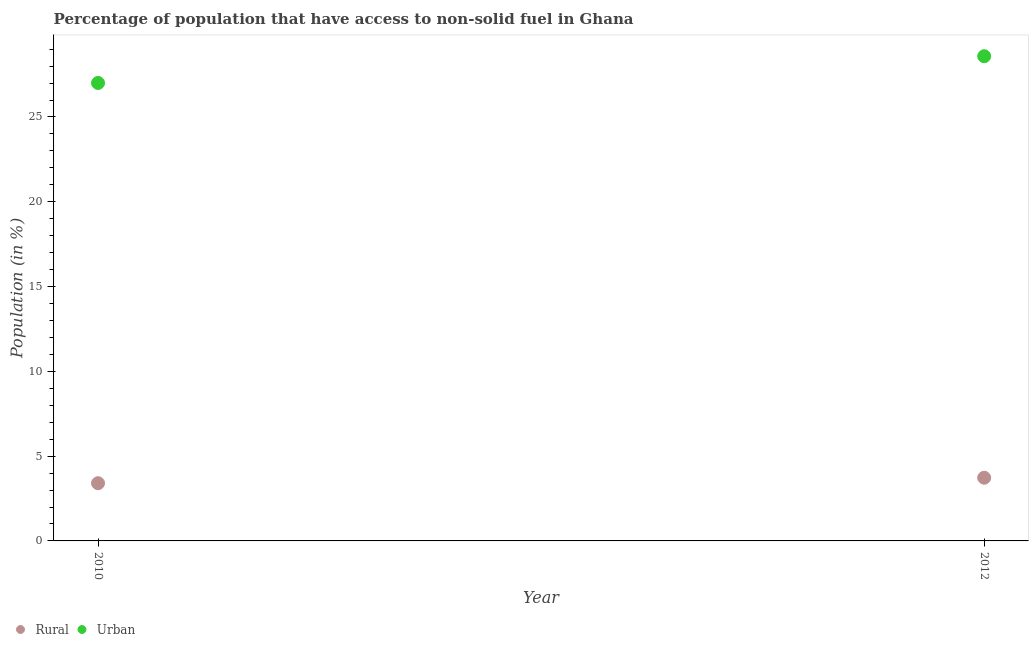How many different coloured dotlines are there?
Your response must be concise. 2. Is the number of dotlines equal to the number of legend labels?
Ensure brevity in your answer.  Yes. What is the rural population in 2010?
Ensure brevity in your answer.  3.4. Across all years, what is the maximum urban population?
Give a very brief answer. 28.58. Across all years, what is the minimum rural population?
Offer a very short reply. 3.4. In which year was the rural population maximum?
Offer a terse response. 2012. In which year was the rural population minimum?
Your answer should be very brief. 2010. What is the total rural population in the graph?
Offer a terse response. 7.13. What is the difference between the rural population in 2010 and that in 2012?
Give a very brief answer. -0.32. What is the difference between the rural population in 2010 and the urban population in 2012?
Your answer should be very brief. -25.18. What is the average rural population per year?
Ensure brevity in your answer.  3.57. In the year 2010, what is the difference between the rural population and urban population?
Give a very brief answer. -23.6. What is the ratio of the rural population in 2010 to that in 2012?
Your response must be concise. 0.91. Is the rural population in 2010 less than that in 2012?
Make the answer very short. Yes. In how many years, is the rural population greater than the average rural population taken over all years?
Make the answer very short. 1. Does the urban population monotonically increase over the years?
Offer a terse response. Yes. Is the urban population strictly greater than the rural population over the years?
Ensure brevity in your answer.  Yes. How many years are there in the graph?
Your answer should be very brief. 2. How many legend labels are there?
Your answer should be compact. 2. How are the legend labels stacked?
Give a very brief answer. Horizontal. What is the title of the graph?
Your response must be concise. Percentage of population that have access to non-solid fuel in Ghana. Does "Diesel" appear as one of the legend labels in the graph?
Offer a terse response. No. What is the Population (in %) in Rural in 2010?
Provide a short and direct response. 3.4. What is the Population (in %) in Urban in 2010?
Your response must be concise. 27.01. What is the Population (in %) of Rural in 2012?
Make the answer very short. 3.73. What is the Population (in %) in Urban in 2012?
Offer a terse response. 28.58. Across all years, what is the maximum Population (in %) of Rural?
Offer a terse response. 3.73. Across all years, what is the maximum Population (in %) of Urban?
Your answer should be very brief. 28.58. Across all years, what is the minimum Population (in %) of Rural?
Give a very brief answer. 3.4. Across all years, what is the minimum Population (in %) in Urban?
Offer a terse response. 27.01. What is the total Population (in %) in Rural in the graph?
Offer a very short reply. 7.13. What is the total Population (in %) of Urban in the graph?
Provide a short and direct response. 55.59. What is the difference between the Population (in %) in Rural in 2010 and that in 2012?
Your response must be concise. -0.32. What is the difference between the Population (in %) in Urban in 2010 and that in 2012?
Ensure brevity in your answer.  -1.58. What is the difference between the Population (in %) in Rural in 2010 and the Population (in %) in Urban in 2012?
Give a very brief answer. -25.18. What is the average Population (in %) of Rural per year?
Provide a succinct answer. 3.57. What is the average Population (in %) in Urban per year?
Offer a terse response. 27.79. In the year 2010, what is the difference between the Population (in %) in Rural and Population (in %) in Urban?
Make the answer very short. -23.6. In the year 2012, what is the difference between the Population (in %) of Rural and Population (in %) of Urban?
Offer a very short reply. -24.86. What is the ratio of the Population (in %) of Rural in 2010 to that in 2012?
Your answer should be very brief. 0.91. What is the ratio of the Population (in %) in Urban in 2010 to that in 2012?
Your answer should be compact. 0.94. What is the difference between the highest and the second highest Population (in %) in Rural?
Offer a terse response. 0.32. What is the difference between the highest and the second highest Population (in %) in Urban?
Offer a very short reply. 1.58. What is the difference between the highest and the lowest Population (in %) of Rural?
Offer a terse response. 0.32. What is the difference between the highest and the lowest Population (in %) of Urban?
Provide a succinct answer. 1.58. 